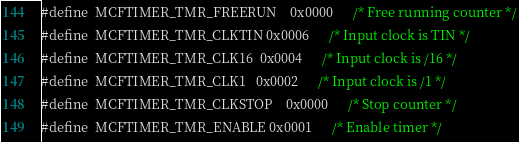<code> <loc_0><loc_0><loc_500><loc_500><_C_>#define	MCFTIMER_TMR_FREERUN	0x0000		/* Free running counter */
#define	MCFTIMER_TMR_CLKTIN	0x0006		/* Input clock is TIN */
#define	MCFTIMER_TMR_CLK16	0x0004		/* Input clock is /16 */
#define	MCFTIMER_TMR_CLK1	0x0002		/* Input clock is /1 */
#define	MCFTIMER_TMR_CLKSTOP	0x0000		/* Stop counter */
#define	MCFTIMER_TMR_ENABLE	0x0001		/* Enable timer */</code> 